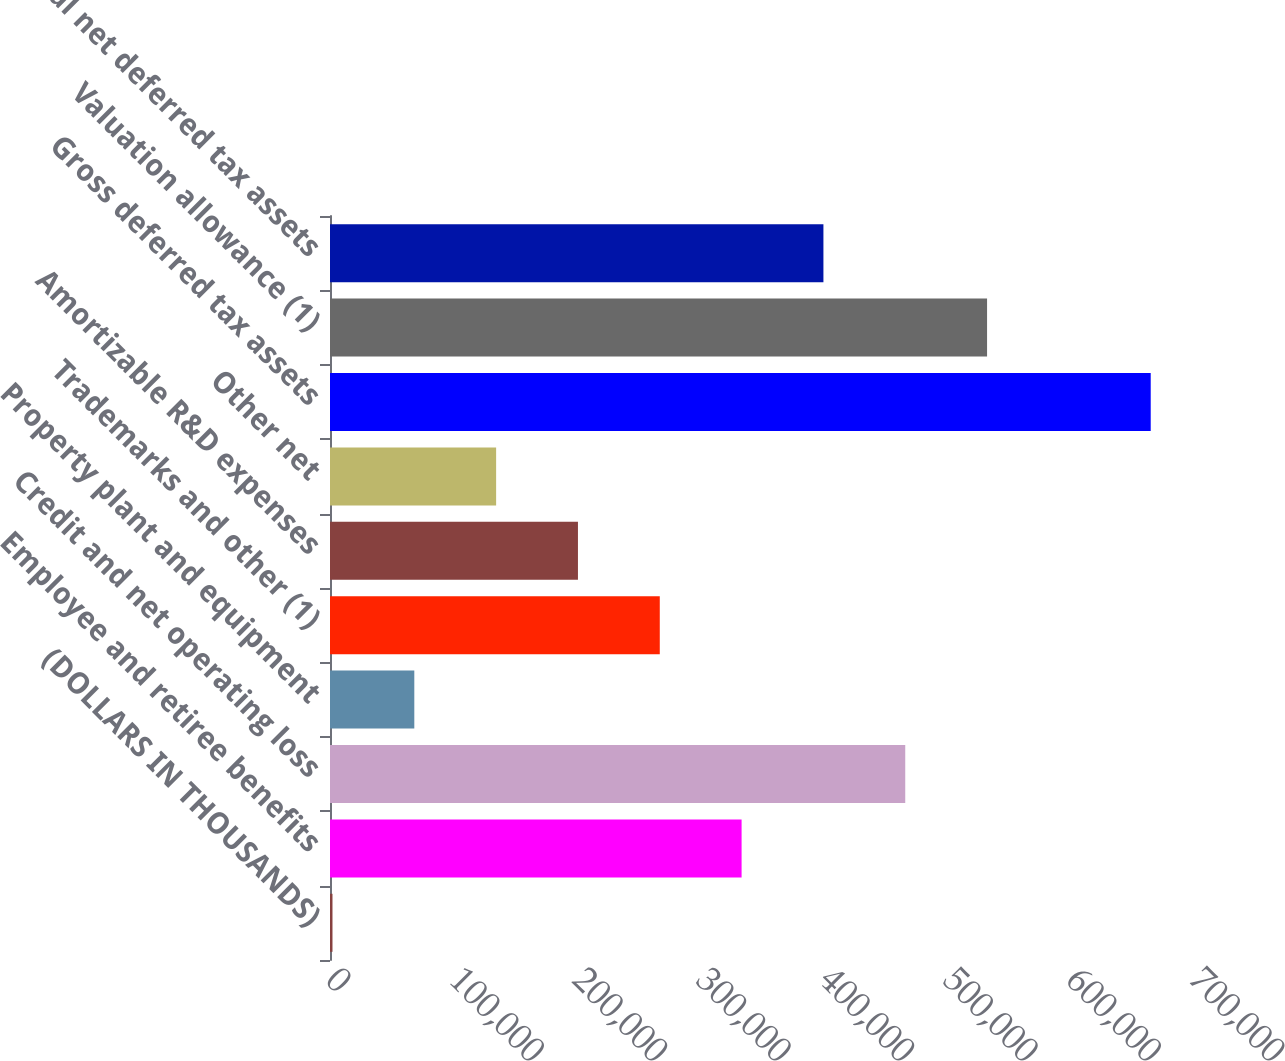<chart> <loc_0><loc_0><loc_500><loc_500><bar_chart><fcel>(DOLLARS IN THOUSANDS)<fcel>Employee and retiree benefits<fcel>Credit and net operating loss<fcel>Property plant and equipment<fcel>Trademarks and other (1)<fcel>Amortizable R&D expenses<fcel>Other net<fcel>Gross deferred tax assets<fcel>Valuation allowance (1)<fcel>Total net deferred tax assets<nl><fcel>2012<fcel>333470<fcel>466053<fcel>68303.6<fcel>267178<fcel>200887<fcel>134595<fcel>664928<fcel>532345<fcel>399762<nl></chart> 